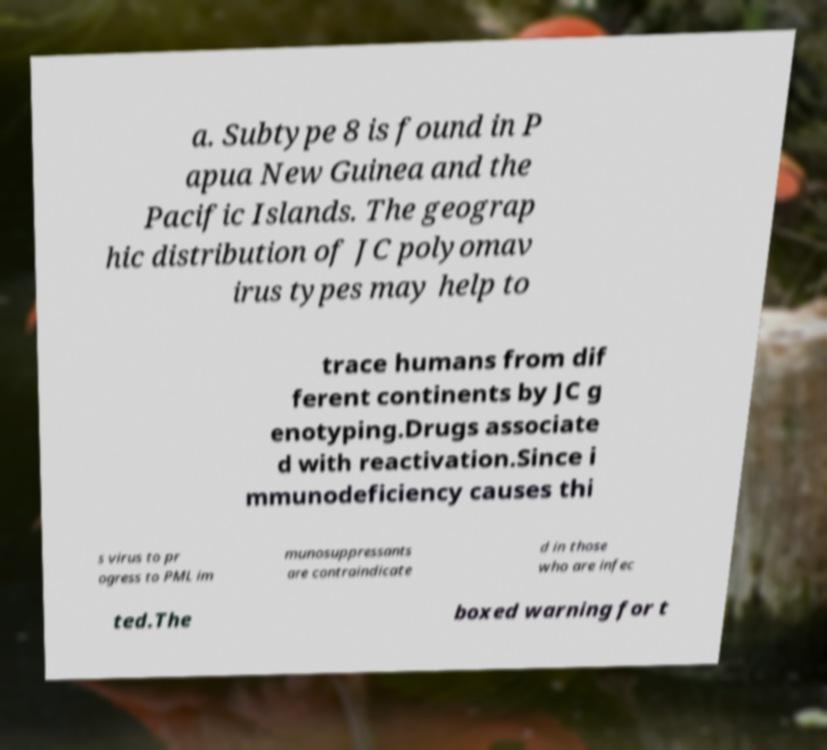There's text embedded in this image that I need extracted. Can you transcribe it verbatim? a. Subtype 8 is found in P apua New Guinea and the Pacific Islands. The geograp hic distribution of JC polyomav irus types may help to trace humans from dif ferent continents by JC g enotyping.Drugs associate d with reactivation.Since i mmunodeficiency causes thi s virus to pr ogress to PML im munosuppressants are contraindicate d in those who are infec ted.The boxed warning for t 